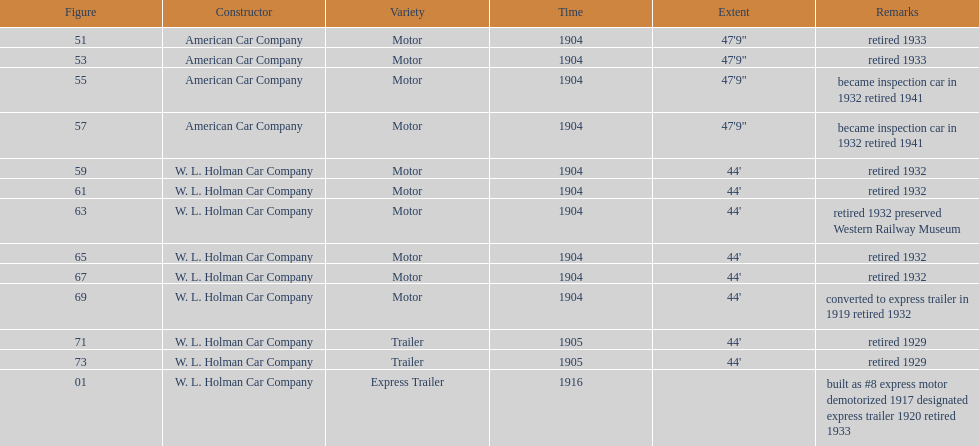What was the number of cars built by american car company? 4. 